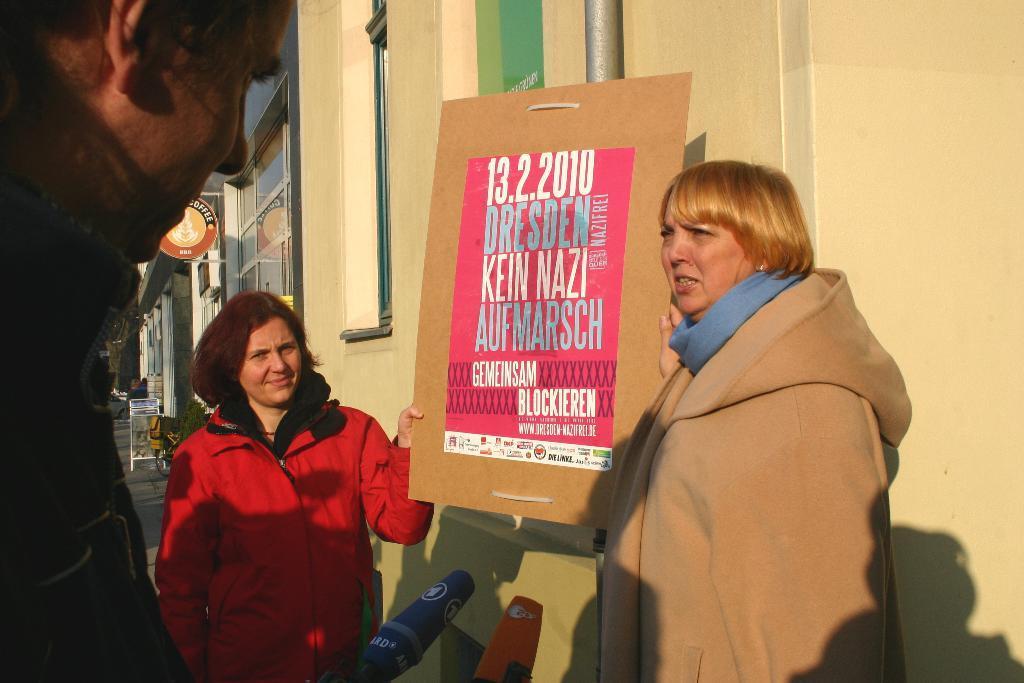Please provide a concise description of this image. There are two persons standing at the bottom of this image are holding a poster. There is one person standing on the left side is holding a Mic. There is a building in the background. 